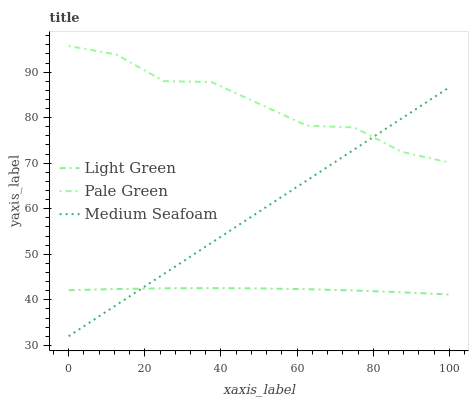Does Medium Seafoam have the minimum area under the curve?
Answer yes or no. No. Does Medium Seafoam have the maximum area under the curve?
Answer yes or no. No. Is Light Green the smoothest?
Answer yes or no. No. Is Light Green the roughest?
Answer yes or no. No. Does Light Green have the lowest value?
Answer yes or no. No. Does Medium Seafoam have the highest value?
Answer yes or no. No. Is Light Green less than Pale Green?
Answer yes or no. Yes. Is Pale Green greater than Light Green?
Answer yes or no. Yes. Does Light Green intersect Pale Green?
Answer yes or no. No. 